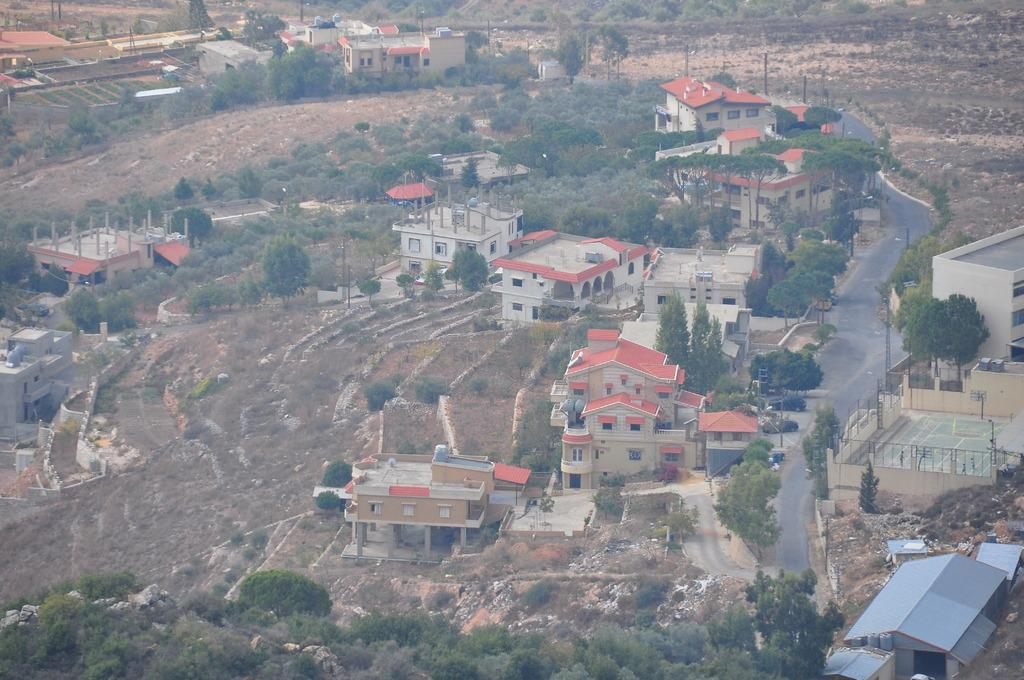What type of structures are visible in the image? There are houses in the image. What type of vegetation is present in the image? There are trees and plants in the image. What type of vertical structures can be seen in the image? There are poles in the image. What type of pathway is visible in the image? There is a road in the image. What type of bell can be heard ringing in the image? There is no bell present in the image, and therefore no sound can be heard. What type of feeling is being expressed by the trees in the image? Trees do not have feelings, so this question cannot be answered. 